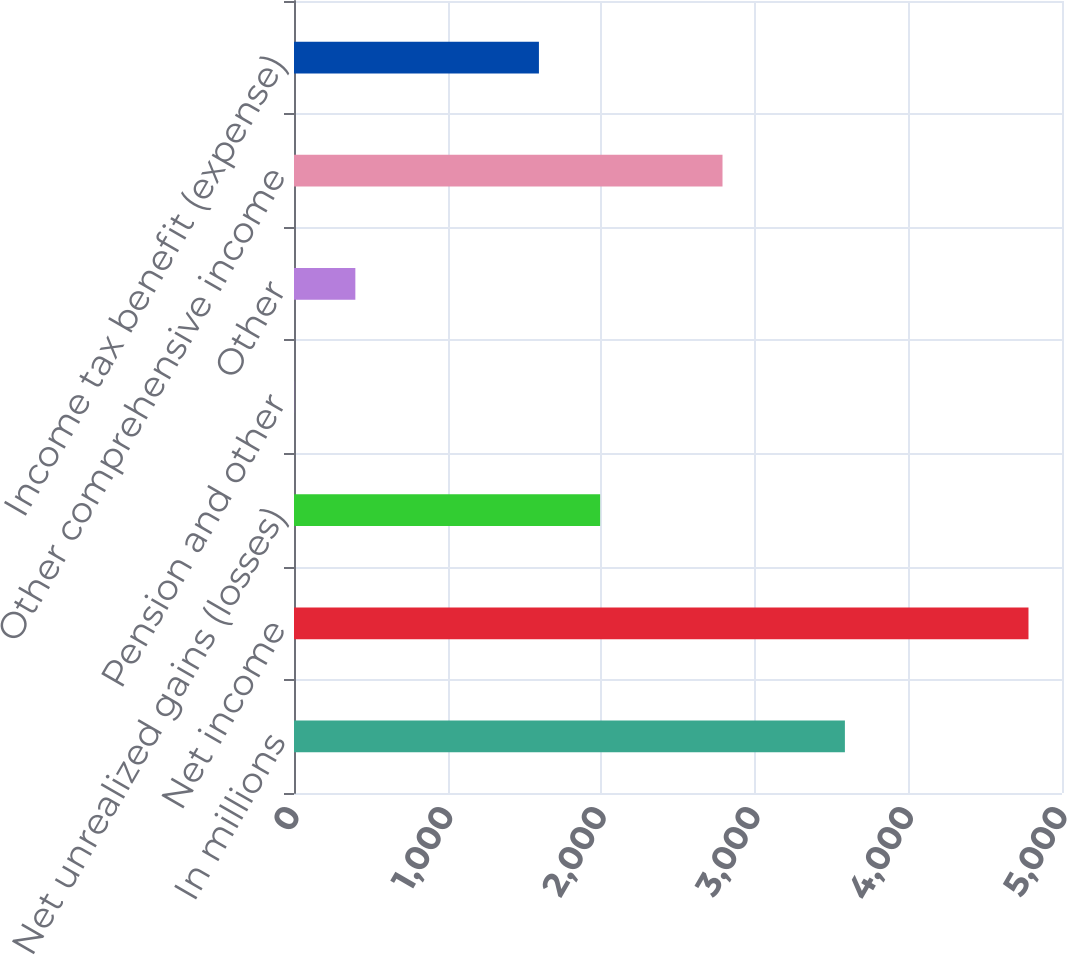Convert chart. <chart><loc_0><loc_0><loc_500><loc_500><bar_chart><fcel>In millions<fcel>Net income<fcel>Net unrealized gains (losses)<fcel>Pension and other<fcel>Other<fcel>Other comprehensive income<fcel>Income tax benefit (expense)<nl><fcel>3586.6<fcel>4781.8<fcel>1993<fcel>1<fcel>399.4<fcel>2789.8<fcel>1594.6<nl></chart> 